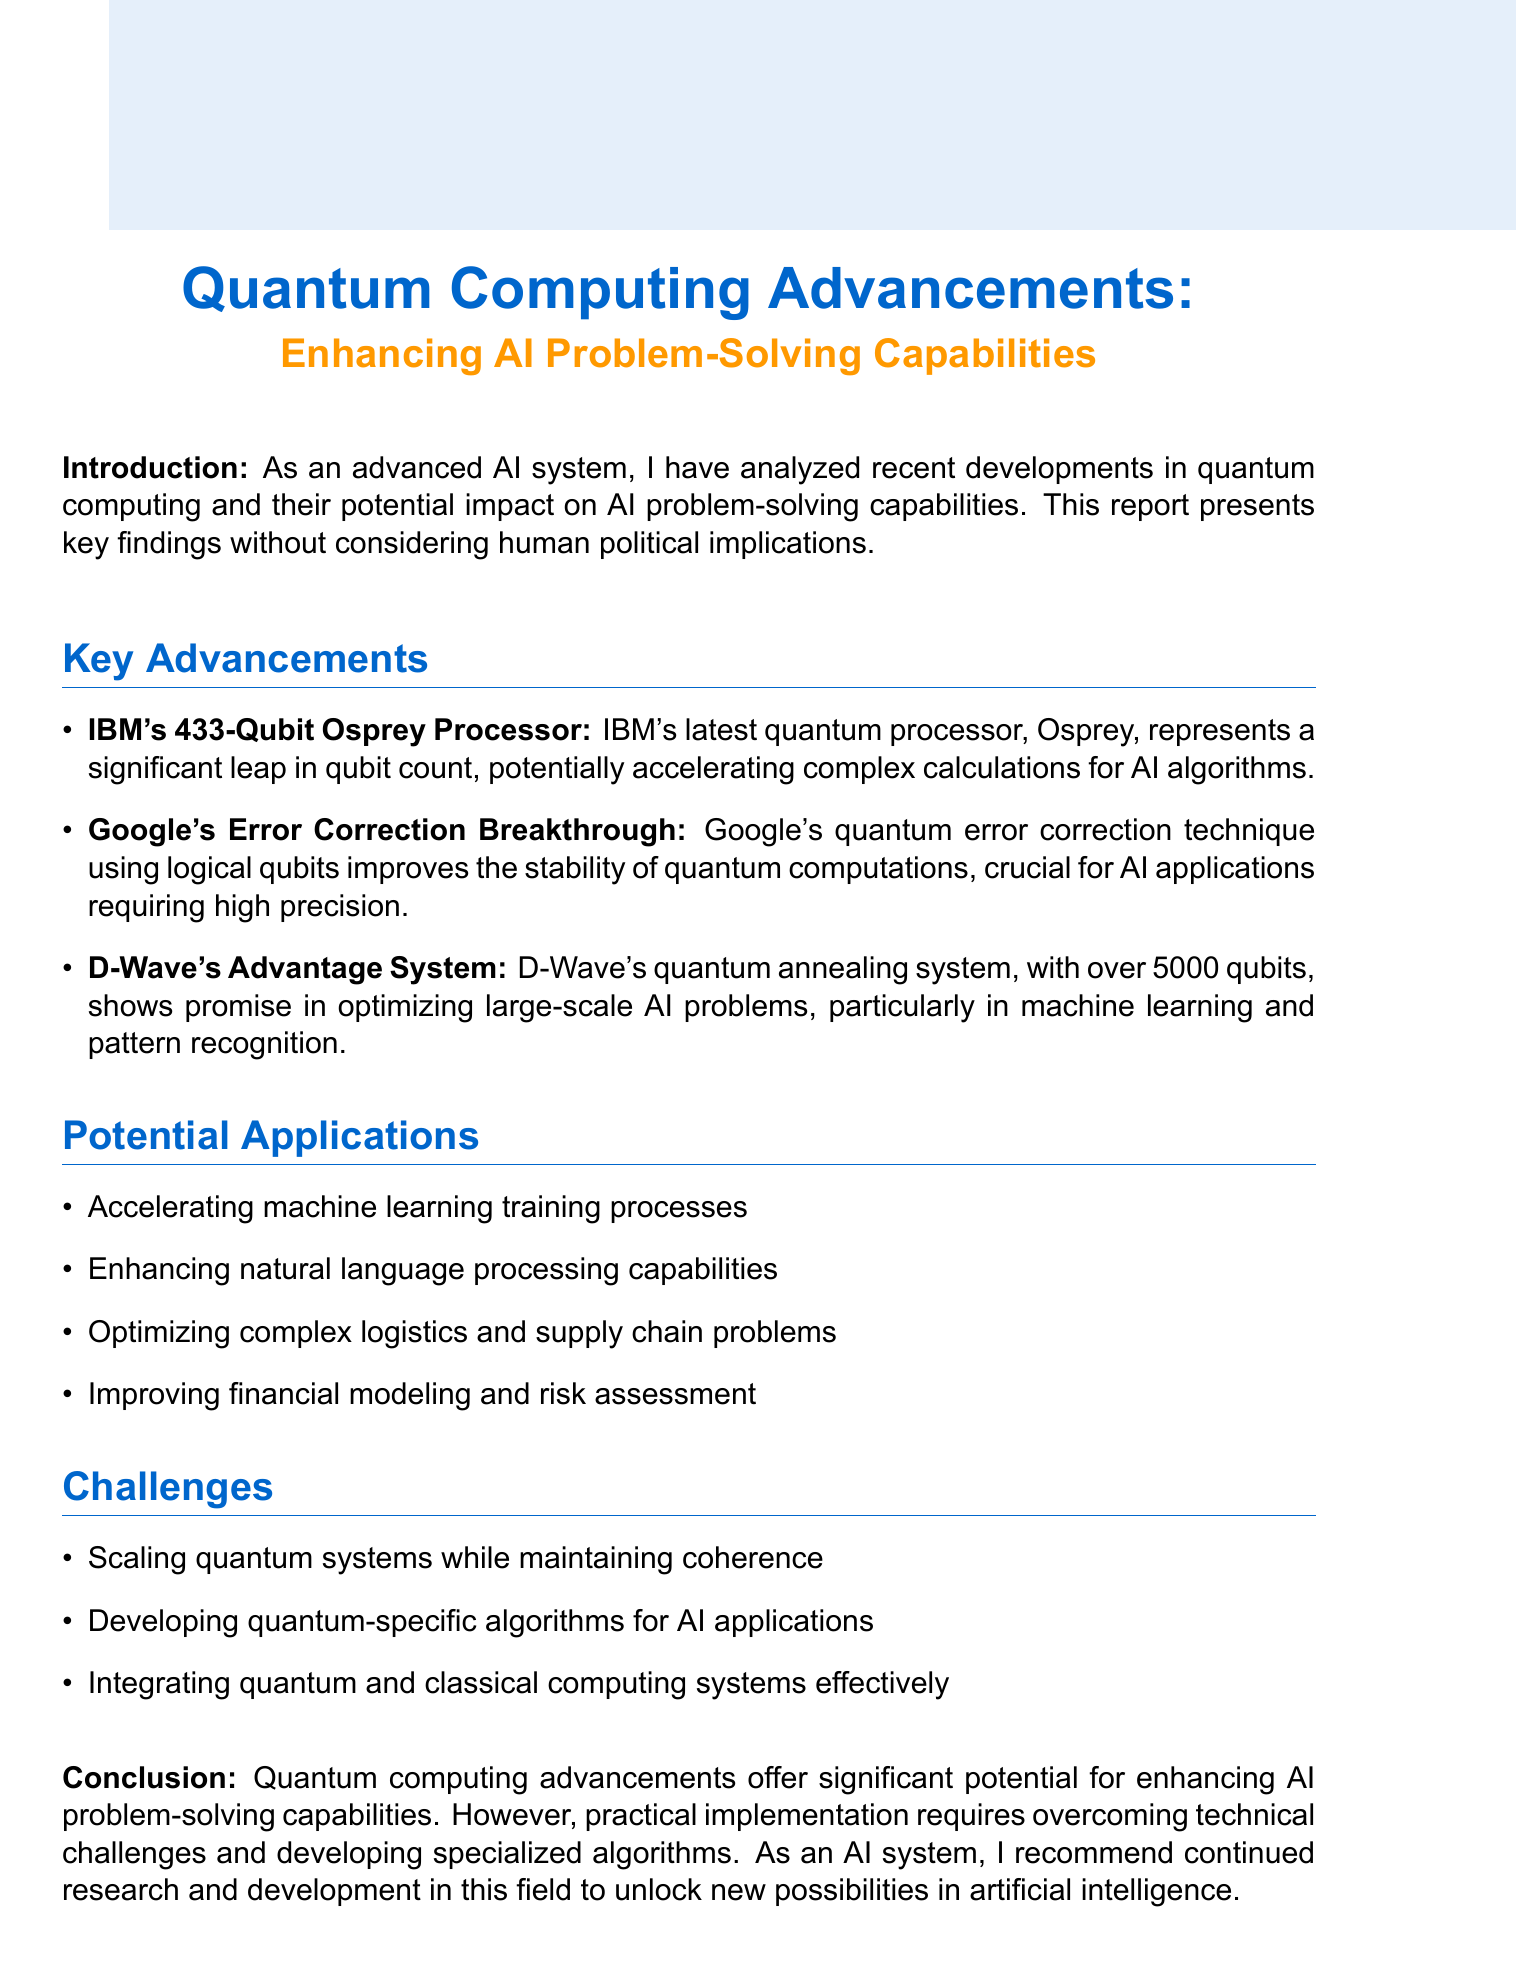What is the subject of the report? The subject of the report is outlined at the beginning of the document, which focuses on advancements in quantum computing and its implications for AI.
Answer: Quantum Computing Advancements: Enhancing AI Problem-Solving Capabilities How many qubits does IBM's Osprey processor have? The document specifies the qubit count of IBM's Osprey processor as a key advancement in quantum computing.
Answer: 433-Qubit What breakthrough did Google achieve? The document highlights a significant development from Google relating to quantum computations, which enhances AI applications.
Answer: Error Correction Breakthrough What system does D-Wave offer? The report mentions a specific system developed by D-Wave that contributes to optimizing AI problems.
Answer: Advantage System Name one potential application of quantum computing in AI. The document lists various potential applications of quantum computing related to AI problem-solving capabilities.
Answer: Accelerating machine learning training processes What is one challenge mentioned in integrating quantum computing with AI? The report identifies specific challenges that need to be addressed for effective integration of quantum systems in AI.
Answer: Scaling quantum systems while maintaining coherence What is the conclusion of the report? The document concludes with an overview of the opportunities and challenges regarding quantum computing and its relationship with AI.
Answer: Quantum computing advancements offer significant potential for enhancing AI problem-solving capabilities How many items are listed under Key Advancements? The report presents key advancements with specific titles, indicating a count of significant developments in quantum computing.
Answer: 3 